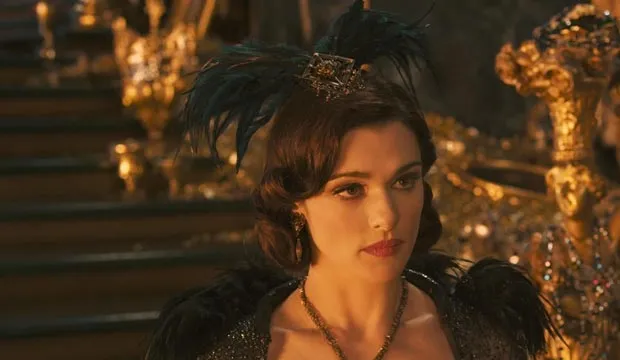Can you describe the main features of this image for me? In this striking image, we see a woman portrayed in a regal manner. She stands in front of an elaborate golden throne, her posture exuding authority and grace. Her attire is an elegant mix of black and gold, perfectly complemented by a black feathered headpiece crowned with gold. The dress drapes beautifully around her, contributing to her commanding presence. Her serious expression and sideward gaze hint at the severity of the scene unfolding. This detailed imagery portrays a strong, authoritative figure in a setting of grandeur and opulence. 